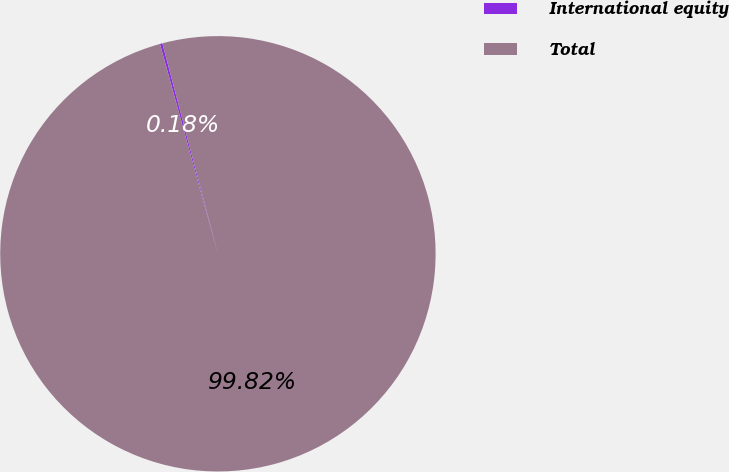Convert chart. <chart><loc_0><loc_0><loc_500><loc_500><pie_chart><fcel>International equity<fcel>Total<nl><fcel>0.18%<fcel>99.82%<nl></chart> 